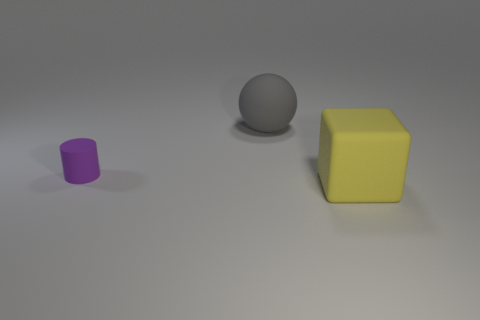What is the material of the thing that is the same size as the yellow cube?
Provide a short and direct response. Rubber. Do the large gray object and the tiny cylinder have the same material?
Keep it short and to the point. Yes. What number of objects are tiny matte objects or metal blocks?
Provide a succinct answer. 1. There is a thing that is in front of the cylinder; what is its shape?
Offer a very short reply. Cube. What color is the large sphere that is made of the same material as the tiny purple cylinder?
Offer a terse response. Gray. The large yellow matte thing has what shape?
Ensure brevity in your answer.  Cube. There is a thing that is both in front of the large gray thing and behind the rubber block; what is it made of?
Give a very brief answer. Rubber. There is a yellow object that is the same material as the purple object; what is its shape?
Ensure brevity in your answer.  Cube. What size is the cylinder that is made of the same material as the big gray ball?
Provide a succinct answer. Small. The object that is both behind the yellow block and to the right of the small purple cylinder has what shape?
Offer a very short reply. Sphere. 